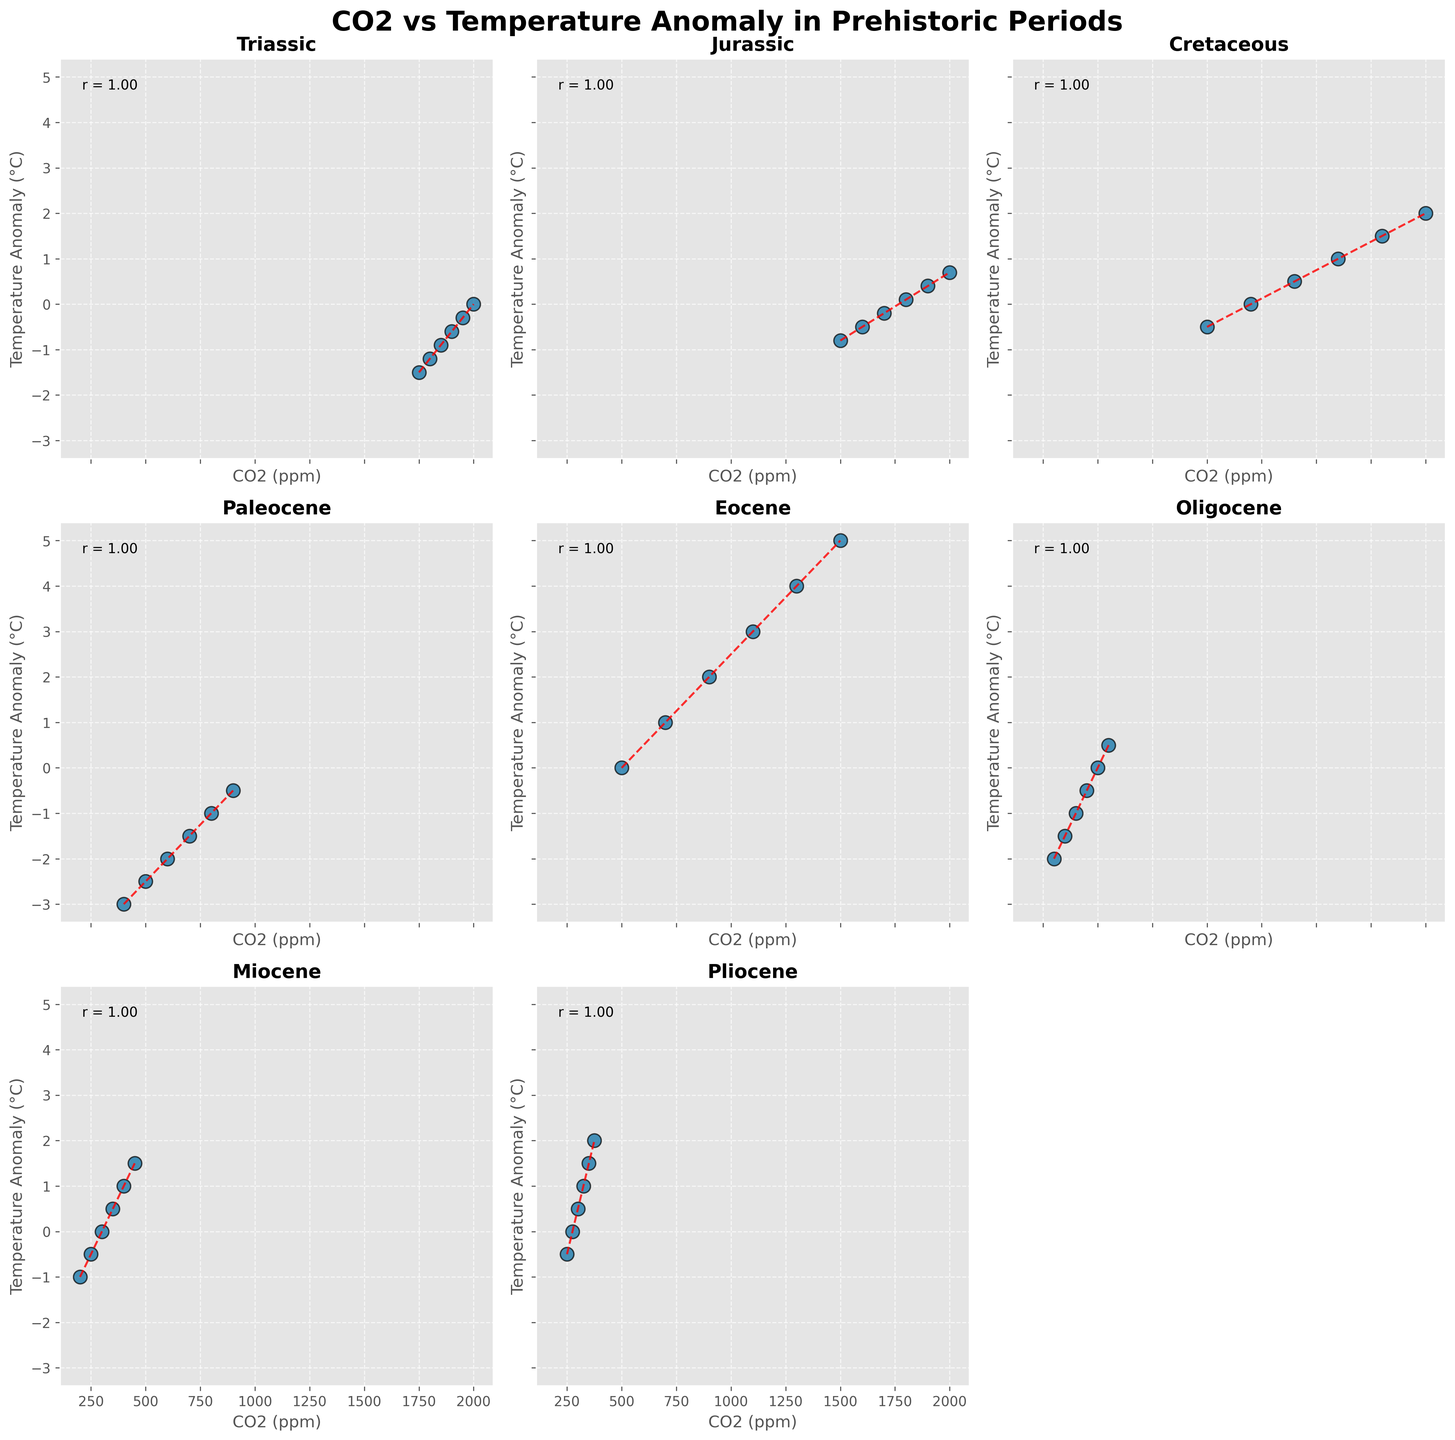What is the correlation coefficient between CO2 and temperature anomaly in the Triassic period? The figure shows the correlation coefficient directly annotated on the subplot for the Triassic period.
Answer: -1.00 Which period has the highest temperature anomaly at 2000 ppm of CO2? By comparing all subplots at 2000 ppm of CO2, we see that the Cretaceous period has the highest temperature anomaly of 2.0°C.
Answer: Cretaceous How does the trend line slope for the Jurassic period compare to the Triassic period? The slope of the trend line for both the periods can be visually compared. The slope in Jurassic appears less steep, indicating a smaller rate of change, while the Triassic has a steeper slope.
Answer: Jurassic < Triassic What is the temperature anomaly difference between the periods Eocene and Miocene at 400 ppm CO2? The subplot for Eocene shows a temperature anomaly of 2.0°C at 400 ppm CO2. The subplot for Miocene shows a temperature anomaly of 1.0°C at 400 ppm CO2. The difference is 2.0 - 1.0 = 1.0.
Answer: 1.0°C Which period's plot has the least positive trend line slope? By visually inspecting the slopes of the trend lines across all subplots, the Oligocene period has the least steep positive slope.
Answer: Oligocene In which period is the temperature anomaly closest to zero at 500 ppm CO2? Upon examining the subplots at 500 ppm CO2, periods including Paleocene and Eocene have a temperature anomaly close to zero, but Eocene hits precisely 0.0°C.
Answer: Eocene What is the visual difference (color and linestyle) of the trend lines in the subplots? All the trend lines in the subplots are red and dashed.
Answer: Red dashed lines Which period has a downward trend in the temperature anomaly with increasing CO2 levels? By looking for periods where the trend line slopes downward, the Triassic period shows a downward trend.
Answer: Triassic 